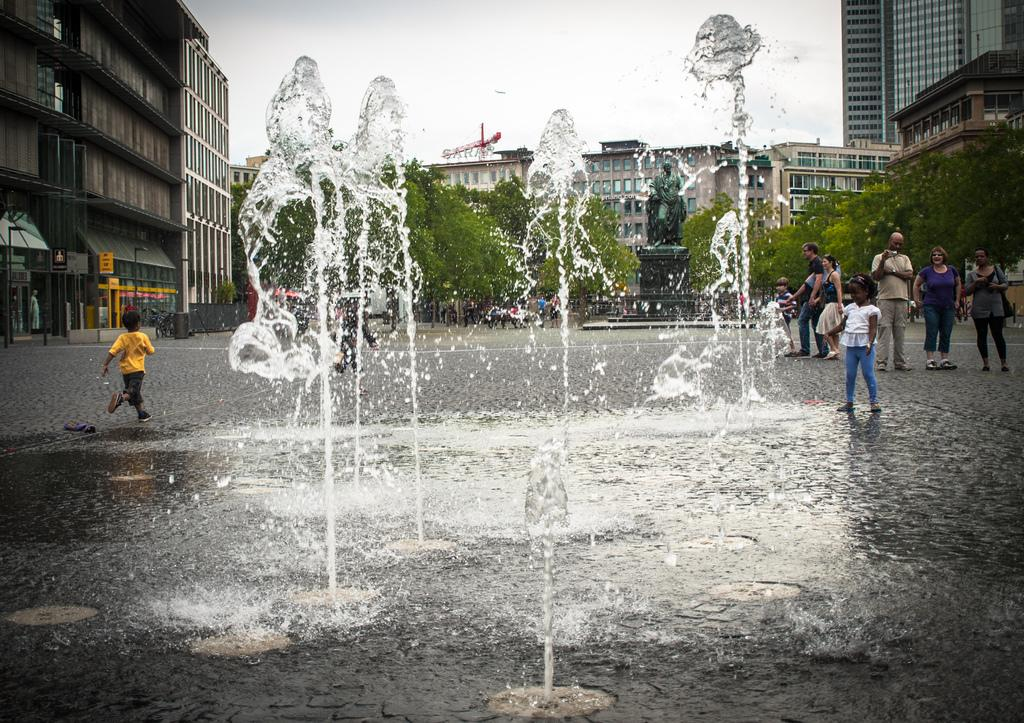What is located in the foreground of the image? There are kids and a water fountain in the foreground of the image. What can be seen in the middle of the image? Buildings, trees, a sculpture, boards, street lights, and people are present in the middle of the image. What is visible at the top of the image? The sky is visible at the top of the image. How many shoes can be seen on the visitors in the image? There is no mention of visitors or shoes in the image; it features kids, a water fountain, buildings, trees, a sculpture, boards, street lights, and people. What event is about to start in the image? There is no indication of an event or a start in the image. 